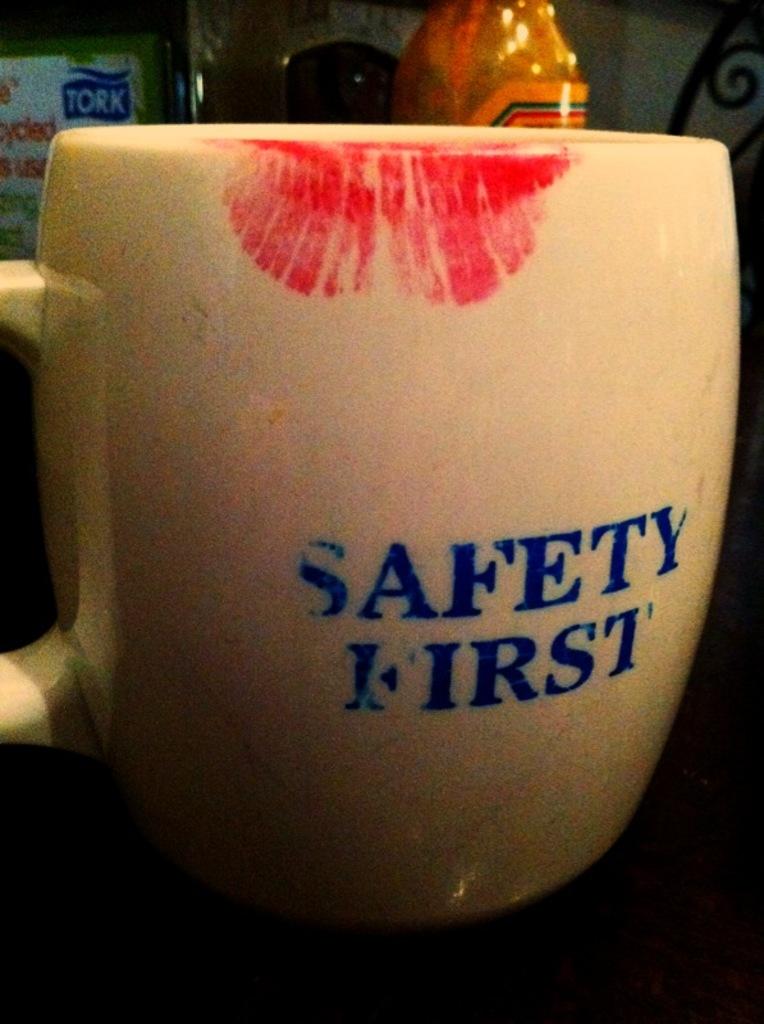What comes first?
Provide a succinct answer. Safety. When should safety come?
Give a very brief answer. First. 